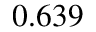Convert formula to latex. <formula><loc_0><loc_0><loc_500><loc_500>0 . 6 3 9</formula> 